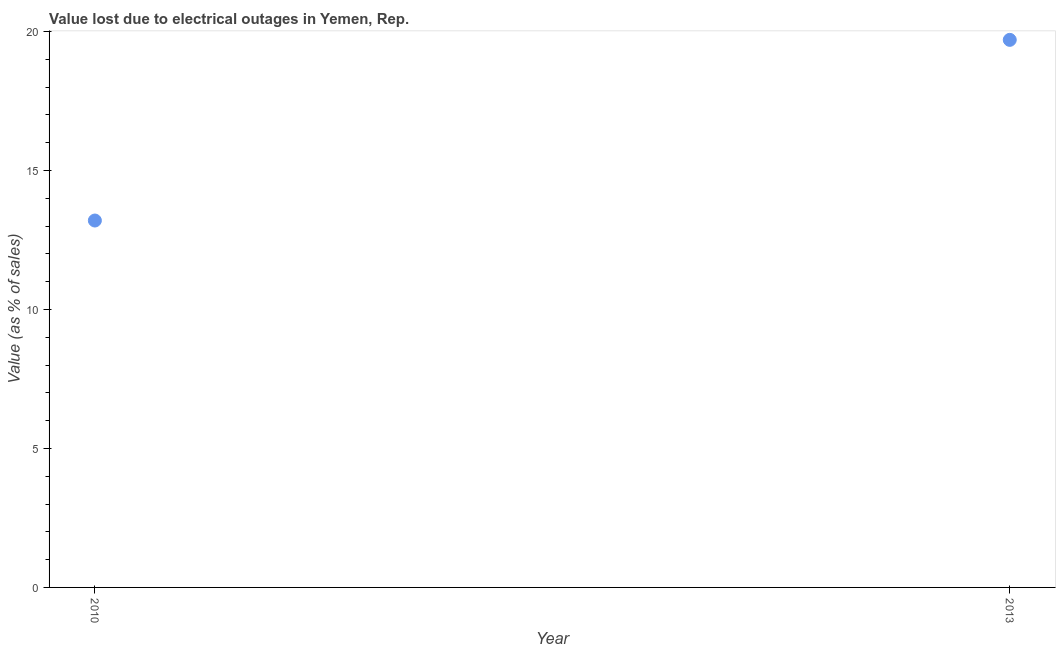What is the value lost due to electrical outages in 2013?
Ensure brevity in your answer.  19.7. Across all years, what is the minimum value lost due to electrical outages?
Offer a very short reply. 13.2. In which year was the value lost due to electrical outages maximum?
Your answer should be very brief. 2013. In which year was the value lost due to electrical outages minimum?
Make the answer very short. 2010. What is the sum of the value lost due to electrical outages?
Ensure brevity in your answer.  32.9. What is the average value lost due to electrical outages per year?
Provide a succinct answer. 16.45. What is the median value lost due to electrical outages?
Provide a succinct answer. 16.45. In how many years, is the value lost due to electrical outages greater than 5 %?
Your response must be concise. 2. What is the ratio of the value lost due to electrical outages in 2010 to that in 2013?
Ensure brevity in your answer.  0.67. Is the value lost due to electrical outages in 2010 less than that in 2013?
Offer a very short reply. Yes. In how many years, is the value lost due to electrical outages greater than the average value lost due to electrical outages taken over all years?
Give a very brief answer. 1. Does the value lost due to electrical outages monotonically increase over the years?
Provide a short and direct response. Yes. How many dotlines are there?
Offer a very short reply. 1. What is the difference between two consecutive major ticks on the Y-axis?
Your response must be concise. 5. Does the graph contain grids?
Your response must be concise. No. What is the title of the graph?
Keep it short and to the point. Value lost due to electrical outages in Yemen, Rep. What is the label or title of the Y-axis?
Your response must be concise. Value (as % of sales). What is the Value (as % of sales) in 2010?
Ensure brevity in your answer.  13.2. What is the Value (as % of sales) in 2013?
Give a very brief answer. 19.7. What is the difference between the Value (as % of sales) in 2010 and 2013?
Give a very brief answer. -6.5. What is the ratio of the Value (as % of sales) in 2010 to that in 2013?
Keep it short and to the point. 0.67. 